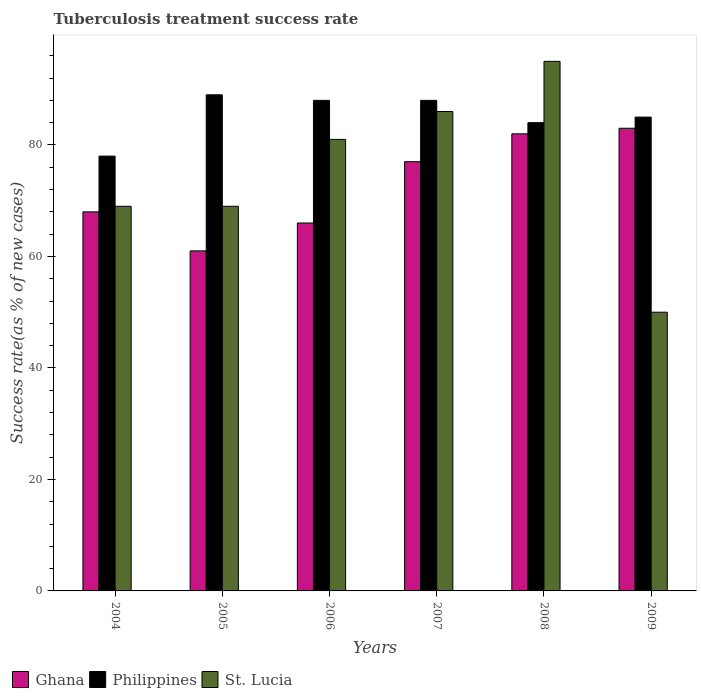How many different coloured bars are there?
Provide a succinct answer. 3. How many groups of bars are there?
Ensure brevity in your answer.  6. Are the number of bars per tick equal to the number of legend labels?
Provide a short and direct response. Yes. How many bars are there on the 3rd tick from the left?
Make the answer very short. 3. How many bars are there on the 2nd tick from the right?
Offer a terse response. 3. What is the label of the 6th group of bars from the left?
Your answer should be compact. 2009. In how many cases, is the number of bars for a given year not equal to the number of legend labels?
Offer a very short reply. 0. What is the tuberculosis treatment success rate in Ghana in 2005?
Your answer should be very brief. 61. Across all years, what is the maximum tuberculosis treatment success rate in Philippines?
Provide a succinct answer. 89. Across all years, what is the minimum tuberculosis treatment success rate in Philippines?
Your response must be concise. 78. In which year was the tuberculosis treatment success rate in Ghana minimum?
Provide a succinct answer. 2005. What is the total tuberculosis treatment success rate in Ghana in the graph?
Give a very brief answer. 437. What is the average tuberculosis treatment success rate in Ghana per year?
Provide a short and direct response. 72.83. In the year 2009, what is the difference between the tuberculosis treatment success rate in St. Lucia and tuberculosis treatment success rate in Ghana?
Ensure brevity in your answer.  -33. What is the ratio of the tuberculosis treatment success rate in Ghana in 2004 to that in 2006?
Ensure brevity in your answer.  1.03. Is the tuberculosis treatment success rate in Ghana in 2004 less than that in 2008?
Ensure brevity in your answer.  Yes. What is the difference between the highest and the second highest tuberculosis treatment success rate in St. Lucia?
Provide a short and direct response. 9. What is the difference between the highest and the lowest tuberculosis treatment success rate in Philippines?
Offer a very short reply. 11. In how many years, is the tuberculosis treatment success rate in St. Lucia greater than the average tuberculosis treatment success rate in St. Lucia taken over all years?
Offer a very short reply. 3. Is the sum of the tuberculosis treatment success rate in Ghana in 2008 and 2009 greater than the maximum tuberculosis treatment success rate in Philippines across all years?
Provide a succinct answer. Yes. How many bars are there?
Provide a short and direct response. 18. How many years are there in the graph?
Provide a short and direct response. 6. Does the graph contain any zero values?
Provide a succinct answer. No. Where does the legend appear in the graph?
Ensure brevity in your answer.  Bottom left. How are the legend labels stacked?
Offer a terse response. Horizontal. What is the title of the graph?
Keep it short and to the point. Tuberculosis treatment success rate. What is the label or title of the Y-axis?
Provide a succinct answer. Success rate(as % of new cases). What is the Success rate(as % of new cases) in Ghana in 2004?
Offer a terse response. 68. What is the Success rate(as % of new cases) in Philippines in 2004?
Offer a very short reply. 78. What is the Success rate(as % of new cases) in Philippines in 2005?
Offer a very short reply. 89. What is the Success rate(as % of new cases) in Philippines in 2006?
Offer a terse response. 88. What is the Success rate(as % of new cases) in Ghana in 2007?
Your answer should be compact. 77. What is the Success rate(as % of new cases) of Philippines in 2007?
Make the answer very short. 88. What is the Success rate(as % of new cases) in St. Lucia in 2007?
Your answer should be compact. 86. What is the Success rate(as % of new cases) of Ghana in 2008?
Ensure brevity in your answer.  82. What is the Success rate(as % of new cases) in Philippines in 2008?
Offer a very short reply. 84. What is the Success rate(as % of new cases) of St. Lucia in 2008?
Your response must be concise. 95. What is the Success rate(as % of new cases) of Philippines in 2009?
Offer a terse response. 85. Across all years, what is the maximum Success rate(as % of new cases) of Ghana?
Keep it short and to the point. 83. Across all years, what is the maximum Success rate(as % of new cases) in Philippines?
Your answer should be compact. 89. What is the total Success rate(as % of new cases) in Ghana in the graph?
Give a very brief answer. 437. What is the total Success rate(as % of new cases) in Philippines in the graph?
Give a very brief answer. 512. What is the total Success rate(as % of new cases) in St. Lucia in the graph?
Provide a short and direct response. 450. What is the difference between the Success rate(as % of new cases) in Ghana in 2004 and that in 2005?
Make the answer very short. 7. What is the difference between the Success rate(as % of new cases) of Philippines in 2004 and that in 2005?
Give a very brief answer. -11. What is the difference between the Success rate(as % of new cases) in Ghana in 2004 and that in 2006?
Give a very brief answer. 2. What is the difference between the Success rate(as % of new cases) in Philippines in 2004 and that in 2006?
Your answer should be very brief. -10. What is the difference between the Success rate(as % of new cases) of St. Lucia in 2004 and that in 2006?
Give a very brief answer. -12. What is the difference between the Success rate(as % of new cases) of Ghana in 2004 and that in 2007?
Offer a very short reply. -9. What is the difference between the Success rate(as % of new cases) in Philippines in 2004 and that in 2007?
Keep it short and to the point. -10. What is the difference between the Success rate(as % of new cases) in Ghana in 2004 and that in 2008?
Give a very brief answer. -14. What is the difference between the Success rate(as % of new cases) in St. Lucia in 2004 and that in 2008?
Your answer should be compact. -26. What is the difference between the Success rate(as % of new cases) in St. Lucia in 2004 and that in 2009?
Provide a short and direct response. 19. What is the difference between the Success rate(as % of new cases) in Philippines in 2005 and that in 2007?
Provide a succinct answer. 1. What is the difference between the Success rate(as % of new cases) of Ghana in 2005 and that in 2008?
Keep it short and to the point. -21. What is the difference between the Success rate(as % of new cases) of Philippines in 2005 and that in 2008?
Offer a terse response. 5. What is the difference between the Success rate(as % of new cases) of St. Lucia in 2005 and that in 2009?
Provide a succinct answer. 19. What is the difference between the Success rate(as % of new cases) in Philippines in 2006 and that in 2007?
Provide a short and direct response. 0. What is the difference between the Success rate(as % of new cases) in Philippines in 2006 and that in 2008?
Your answer should be compact. 4. What is the difference between the Success rate(as % of new cases) of St. Lucia in 2006 and that in 2008?
Offer a very short reply. -14. What is the difference between the Success rate(as % of new cases) in St. Lucia in 2006 and that in 2009?
Your response must be concise. 31. What is the difference between the Success rate(as % of new cases) of St. Lucia in 2007 and that in 2008?
Offer a very short reply. -9. What is the difference between the Success rate(as % of new cases) in Ghana in 2007 and that in 2009?
Ensure brevity in your answer.  -6. What is the difference between the Success rate(as % of new cases) in St. Lucia in 2007 and that in 2009?
Your answer should be very brief. 36. What is the difference between the Success rate(as % of new cases) of Philippines in 2008 and that in 2009?
Keep it short and to the point. -1. What is the difference between the Success rate(as % of new cases) of Ghana in 2004 and the Success rate(as % of new cases) of Philippines in 2005?
Keep it short and to the point. -21. What is the difference between the Success rate(as % of new cases) of Ghana in 2004 and the Success rate(as % of new cases) of St. Lucia in 2005?
Provide a short and direct response. -1. What is the difference between the Success rate(as % of new cases) of Philippines in 2004 and the Success rate(as % of new cases) of St. Lucia in 2005?
Provide a succinct answer. 9. What is the difference between the Success rate(as % of new cases) in Ghana in 2004 and the Success rate(as % of new cases) in Philippines in 2007?
Your answer should be compact. -20. What is the difference between the Success rate(as % of new cases) of Philippines in 2004 and the Success rate(as % of new cases) of St. Lucia in 2007?
Offer a very short reply. -8. What is the difference between the Success rate(as % of new cases) of Ghana in 2004 and the Success rate(as % of new cases) of Philippines in 2008?
Keep it short and to the point. -16. What is the difference between the Success rate(as % of new cases) of Philippines in 2004 and the Success rate(as % of new cases) of St. Lucia in 2008?
Your answer should be compact. -17. What is the difference between the Success rate(as % of new cases) of Ghana in 2004 and the Success rate(as % of new cases) of St. Lucia in 2009?
Ensure brevity in your answer.  18. What is the difference between the Success rate(as % of new cases) of Philippines in 2004 and the Success rate(as % of new cases) of St. Lucia in 2009?
Offer a very short reply. 28. What is the difference between the Success rate(as % of new cases) in Ghana in 2005 and the Success rate(as % of new cases) in St. Lucia in 2006?
Offer a very short reply. -20. What is the difference between the Success rate(as % of new cases) in Ghana in 2005 and the Success rate(as % of new cases) in Philippines in 2007?
Ensure brevity in your answer.  -27. What is the difference between the Success rate(as % of new cases) in Ghana in 2005 and the Success rate(as % of new cases) in St. Lucia in 2007?
Provide a short and direct response. -25. What is the difference between the Success rate(as % of new cases) of Ghana in 2005 and the Success rate(as % of new cases) of St. Lucia in 2008?
Provide a succinct answer. -34. What is the difference between the Success rate(as % of new cases) of Ghana in 2005 and the Success rate(as % of new cases) of St. Lucia in 2009?
Provide a short and direct response. 11. What is the difference between the Success rate(as % of new cases) in Philippines in 2005 and the Success rate(as % of new cases) in St. Lucia in 2009?
Ensure brevity in your answer.  39. What is the difference between the Success rate(as % of new cases) of Ghana in 2006 and the Success rate(as % of new cases) of Philippines in 2007?
Give a very brief answer. -22. What is the difference between the Success rate(as % of new cases) of Ghana in 2006 and the Success rate(as % of new cases) of St. Lucia in 2007?
Your response must be concise. -20. What is the difference between the Success rate(as % of new cases) of Philippines in 2006 and the Success rate(as % of new cases) of St. Lucia in 2007?
Provide a succinct answer. 2. What is the difference between the Success rate(as % of new cases) of Ghana in 2006 and the Success rate(as % of new cases) of St. Lucia in 2008?
Keep it short and to the point. -29. What is the difference between the Success rate(as % of new cases) of Ghana in 2006 and the Success rate(as % of new cases) of Philippines in 2009?
Ensure brevity in your answer.  -19. What is the difference between the Success rate(as % of new cases) of Ghana in 2006 and the Success rate(as % of new cases) of St. Lucia in 2009?
Your answer should be compact. 16. What is the difference between the Success rate(as % of new cases) in Philippines in 2006 and the Success rate(as % of new cases) in St. Lucia in 2009?
Ensure brevity in your answer.  38. What is the difference between the Success rate(as % of new cases) of Ghana in 2007 and the Success rate(as % of new cases) of St. Lucia in 2008?
Keep it short and to the point. -18. What is the difference between the Success rate(as % of new cases) in Philippines in 2007 and the Success rate(as % of new cases) in St. Lucia in 2008?
Ensure brevity in your answer.  -7. What is the difference between the Success rate(as % of new cases) of Ghana in 2007 and the Success rate(as % of new cases) of St. Lucia in 2009?
Offer a terse response. 27. What is the difference between the Success rate(as % of new cases) of Philippines in 2007 and the Success rate(as % of new cases) of St. Lucia in 2009?
Keep it short and to the point. 38. What is the difference between the Success rate(as % of new cases) in Ghana in 2008 and the Success rate(as % of new cases) in Philippines in 2009?
Make the answer very short. -3. What is the difference between the Success rate(as % of new cases) of Ghana in 2008 and the Success rate(as % of new cases) of St. Lucia in 2009?
Provide a succinct answer. 32. What is the average Success rate(as % of new cases) of Ghana per year?
Provide a short and direct response. 72.83. What is the average Success rate(as % of new cases) in Philippines per year?
Keep it short and to the point. 85.33. What is the average Success rate(as % of new cases) of St. Lucia per year?
Your response must be concise. 75. In the year 2004, what is the difference between the Success rate(as % of new cases) of Ghana and Success rate(as % of new cases) of Philippines?
Your response must be concise. -10. In the year 2004, what is the difference between the Success rate(as % of new cases) in Ghana and Success rate(as % of new cases) in St. Lucia?
Give a very brief answer. -1. In the year 2005, what is the difference between the Success rate(as % of new cases) in Ghana and Success rate(as % of new cases) in Philippines?
Give a very brief answer. -28. In the year 2006, what is the difference between the Success rate(as % of new cases) in Ghana and Success rate(as % of new cases) in Philippines?
Provide a short and direct response. -22. In the year 2006, what is the difference between the Success rate(as % of new cases) of Ghana and Success rate(as % of new cases) of St. Lucia?
Make the answer very short. -15. In the year 2006, what is the difference between the Success rate(as % of new cases) of Philippines and Success rate(as % of new cases) of St. Lucia?
Provide a succinct answer. 7. In the year 2007, what is the difference between the Success rate(as % of new cases) of Ghana and Success rate(as % of new cases) of St. Lucia?
Offer a very short reply. -9. In the year 2007, what is the difference between the Success rate(as % of new cases) in Philippines and Success rate(as % of new cases) in St. Lucia?
Ensure brevity in your answer.  2. In the year 2008, what is the difference between the Success rate(as % of new cases) in Ghana and Success rate(as % of new cases) in Philippines?
Your answer should be very brief. -2. In the year 2008, what is the difference between the Success rate(as % of new cases) of Philippines and Success rate(as % of new cases) of St. Lucia?
Your answer should be compact. -11. In the year 2009, what is the difference between the Success rate(as % of new cases) in Ghana and Success rate(as % of new cases) in Philippines?
Provide a succinct answer. -2. In the year 2009, what is the difference between the Success rate(as % of new cases) of Philippines and Success rate(as % of new cases) of St. Lucia?
Ensure brevity in your answer.  35. What is the ratio of the Success rate(as % of new cases) in Ghana in 2004 to that in 2005?
Make the answer very short. 1.11. What is the ratio of the Success rate(as % of new cases) of Philippines in 2004 to that in 2005?
Your response must be concise. 0.88. What is the ratio of the Success rate(as % of new cases) in Ghana in 2004 to that in 2006?
Offer a very short reply. 1.03. What is the ratio of the Success rate(as % of new cases) in Philippines in 2004 to that in 2006?
Your response must be concise. 0.89. What is the ratio of the Success rate(as % of new cases) in St. Lucia in 2004 to that in 2006?
Provide a succinct answer. 0.85. What is the ratio of the Success rate(as % of new cases) of Ghana in 2004 to that in 2007?
Keep it short and to the point. 0.88. What is the ratio of the Success rate(as % of new cases) of Philippines in 2004 to that in 2007?
Offer a terse response. 0.89. What is the ratio of the Success rate(as % of new cases) in St. Lucia in 2004 to that in 2007?
Provide a short and direct response. 0.8. What is the ratio of the Success rate(as % of new cases) of Ghana in 2004 to that in 2008?
Provide a succinct answer. 0.83. What is the ratio of the Success rate(as % of new cases) of Philippines in 2004 to that in 2008?
Keep it short and to the point. 0.93. What is the ratio of the Success rate(as % of new cases) of St. Lucia in 2004 to that in 2008?
Offer a terse response. 0.73. What is the ratio of the Success rate(as % of new cases) of Ghana in 2004 to that in 2009?
Provide a short and direct response. 0.82. What is the ratio of the Success rate(as % of new cases) in Philippines in 2004 to that in 2009?
Make the answer very short. 0.92. What is the ratio of the Success rate(as % of new cases) of St. Lucia in 2004 to that in 2009?
Your answer should be very brief. 1.38. What is the ratio of the Success rate(as % of new cases) in Ghana in 2005 to that in 2006?
Your answer should be compact. 0.92. What is the ratio of the Success rate(as % of new cases) of Philippines in 2005 to that in 2006?
Your answer should be compact. 1.01. What is the ratio of the Success rate(as % of new cases) in St. Lucia in 2005 to that in 2006?
Offer a terse response. 0.85. What is the ratio of the Success rate(as % of new cases) of Ghana in 2005 to that in 2007?
Give a very brief answer. 0.79. What is the ratio of the Success rate(as % of new cases) of Philippines in 2005 to that in 2007?
Your answer should be very brief. 1.01. What is the ratio of the Success rate(as % of new cases) of St. Lucia in 2005 to that in 2007?
Your answer should be very brief. 0.8. What is the ratio of the Success rate(as % of new cases) in Ghana in 2005 to that in 2008?
Provide a short and direct response. 0.74. What is the ratio of the Success rate(as % of new cases) in Philippines in 2005 to that in 2008?
Provide a short and direct response. 1.06. What is the ratio of the Success rate(as % of new cases) in St. Lucia in 2005 to that in 2008?
Give a very brief answer. 0.73. What is the ratio of the Success rate(as % of new cases) of Ghana in 2005 to that in 2009?
Make the answer very short. 0.73. What is the ratio of the Success rate(as % of new cases) in Philippines in 2005 to that in 2009?
Provide a succinct answer. 1.05. What is the ratio of the Success rate(as % of new cases) of St. Lucia in 2005 to that in 2009?
Provide a short and direct response. 1.38. What is the ratio of the Success rate(as % of new cases) of St. Lucia in 2006 to that in 2007?
Ensure brevity in your answer.  0.94. What is the ratio of the Success rate(as % of new cases) in Ghana in 2006 to that in 2008?
Offer a very short reply. 0.8. What is the ratio of the Success rate(as % of new cases) in Philippines in 2006 to that in 2008?
Your answer should be compact. 1.05. What is the ratio of the Success rate(as % of new cases) in St. Lucia in 2006 to that in 2008?
Your answer should be very brief. 0.85. What is the ratio of the Success rate(as % of new cases) in Ghana in 2006 to that in 2009?
Make the answer very short. 0.8. What is the ratio of the Success rate(as % of new cases) of Philippines in 2006 to that in 2009?
Give a very brief answer. 1.04. What is the ratio of the Success rate(as % of new cases) of St. Lucia in 2006 to that in 2009?
Keep it short and to the point. 1.62. What is the ratio of the Success rate(as % of new cases) in Ghana in 2007 to that in 2008?
Your answer should be compact. 0.94. What is the ratio of the Success rate(as % of new cases) of Philippines in 2007 to that in 2008?
Your answer should be compact. 1.05. What is the ratio of the Success rate(as % of new cases) of St. Lucia in 2007 to that in 2008?
Provide a short and direct response. 0.91. What is the ratio of the Success rate(as % of new cases) of Ghana in 2007 to that in 2009?
Keep it short and to the point. 0.93. What is the ratio of the Success rate(as % of new cases) in Philippines in 2007 to that in 2009?
Keep it short and to the point. 1.04. What is the ratio of the Success rate(as % of new cases) of St. Lucia in 2007 to that in 2009?
Make the answer very short. 1.72. What is the ratio of the Success rate(as % of new cases) of Ghana in 2008 to that in 2009?
Give a very brief answer. 0.99. What is the ratio of the Success rate(as % of new cases) of St. Lucia in 2008 to that in 2009?
Your answer should be compact. 1.9. What is the difference between the highest and the lowest Success rate(as % of new cases) of Ghana?
Make the answer very short. 22. What is the difference between the highest and the lowest Success rate(as % of new cases) in Philippines?
Keep it short and to the point. 11. 